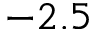Convert formula to latex. <formula><loc_0><loc_0><loc_500><loc_500>- 2 . 5</formula> 